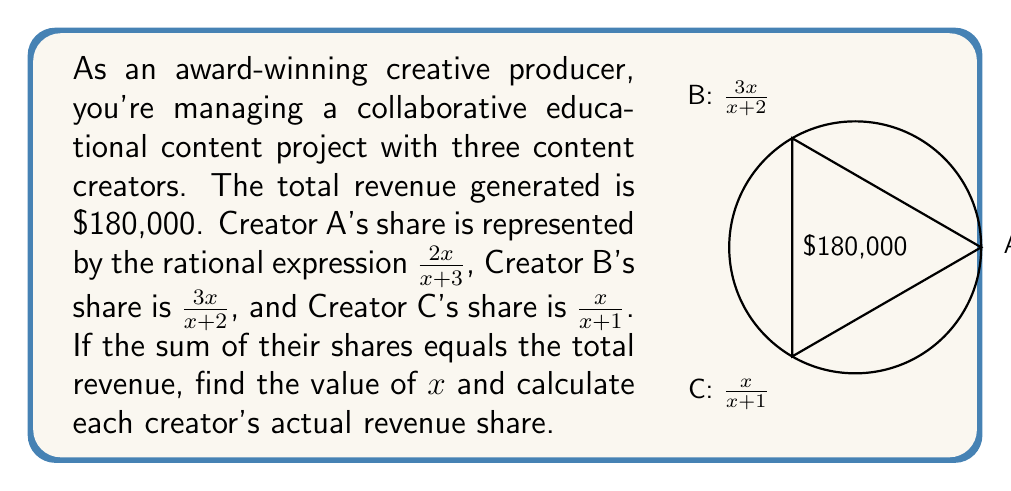Could you help me with this problem? Let's solve this step-by-step:

1) First, we need to set up an equation where the sum of the three shares equals the total revenue:

   $$\frac{2x}{x+3} + \frac{3x}{x+2} + \frac{x}{x+1} = 1$$

   (We use 1 instead of 180,000 as we're working with fractional shares)

2) To add these fractions, we need a common denominator. The least common multiple of $(x+3)$, $(x+2)$, and $(x+1)$ is $(x+3)(x+2)(x+1)$. Multiply each fraction by the appropriate factor:

   $$\frac{2x(x+2)(x+1)}{(x+3)(x+2)(x+1)} + \frac{3x(x+3)(x+1)}{(x+3)(x+2)(x+1)} + \frac{x(x+3)(x+2)}{(x+3)(x+2)(x+1)} = 1$$

3) Simplify the numerators:

   $$\frac{2x(x^2+3x+2)}{(x+3)(x+2)(x+1)} + \frac{3x(x^2+4x+3)}{(x+3)(x+2)(x+1)} + \frac{x(x^2+5x+6)}{(x+3)(x+2)(x+1)} = 1$$

4) Add the numerators:

   $$\frac{2x^3+6x^2+4x + 3x^3+12x^2+9x + x^3+5x^2+6x}{(x+3)(x+2)(x+1)} = 1$$

5) Combine like terms in the numerator:

   $$\frac{6x^3+23x^2+19x}{(x+3)(x+2)(x+1)} = 1$$

6) For this to be true, the numerator must equal the denominator:

   $$6x^3+23x^2+19x = x^3+6x^2+11x+6$$

7) Subtract the right side from both sides:

   $$5x^3+17x^2+8x-6 = 0$$

8) This is a cubic equation. It can be factored as:

   $$(x+2)(5x^2+7x-3) = 0$$

9) Using the quadratic formula or factoring, we find that $x = -2$ or $x = \frac{3}{5}$. Since $x$ can't be negative in this context, $x = \frac{3}{5}$.

10) Now we can calculate each creator's share:

    Creator A: $\frac{2(\frac{3}{5})}{\frac{3}{5}+3} = \frac{6}{11}$
    Creator B: $\frac{3(\frac{3}{5})}{\frac{3}{5}+2} = \frac{9}{13}$
    Creator C: $\frac{\frac{3}{5}}{\frac{3}{5}+1} = \frac{3}{8}$

11) To get the actual revenue, multiply each share by $180,000:

    Creator A: $\frac{6}{11} * 180,000 = 98,181.82$
    Creator B: $\frac{9}{13} * 180,000 = 124,615.38$
    Creator C: $\frac{3}{8} * 180,000 = 67,500.00$
Answer: $x = \frac{3}{5}$; A: $98,181.82, B: $124,615.38, C: $67,500.00 